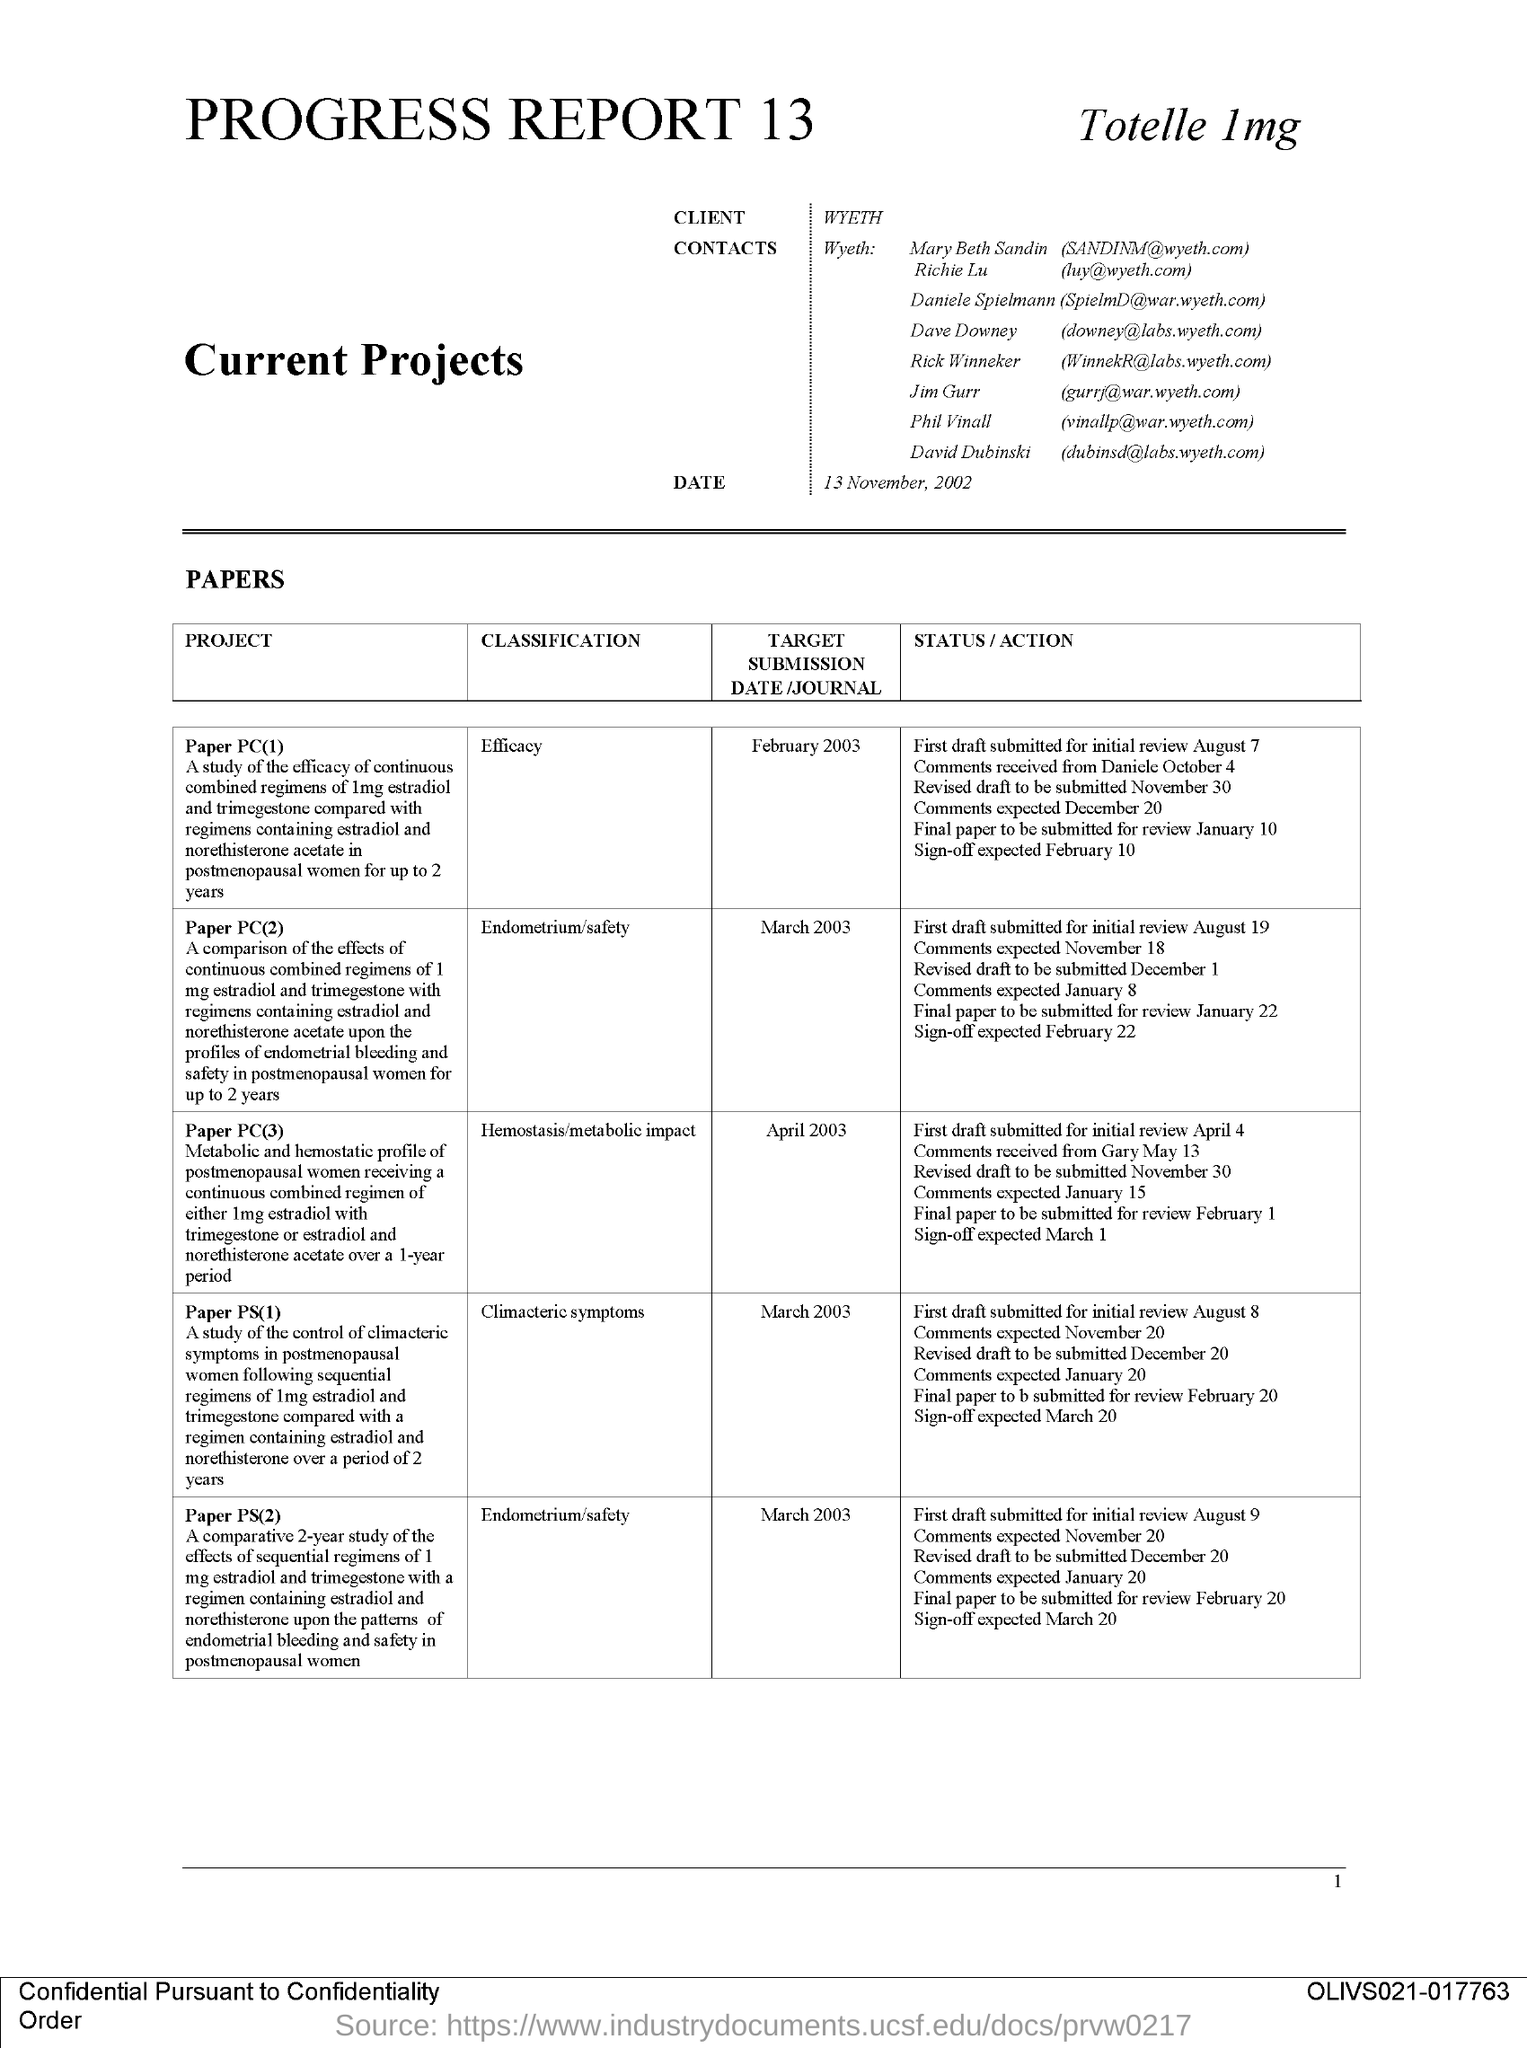Indicate a few pertinent items in this graphic. Paper PS(2)" belongs to the classification of "Endometrium/safety. Paper PS(1)" belongs to the classification of "Climacteric symptoms. Paper PC(3) is classified under the category of Hemostasis/Metabolic Impact. The page number is 1, as indicated by the range '1..'. The client's name is Wyeth. 